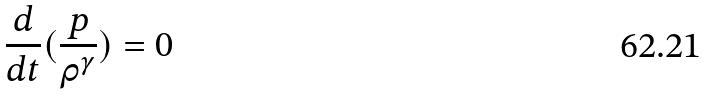Convert formula to latex. <formula><loc_0><loc_0><loc_500><loc_500>\frac { d } { d t } ( \frac { p } { \rho ^ { \gamma } } ) = 0</formula> 